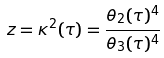<formula> <loc_0><loc_0><loc_500><loc_500>z = \kappa ^ { 2 } ( \tau ) = { \frac { \theta _ { 2 } ( \tau ) ^ { 4 } } { \theta _ { 3 } ( \tau ) ^ { 4 } } }</formula> 